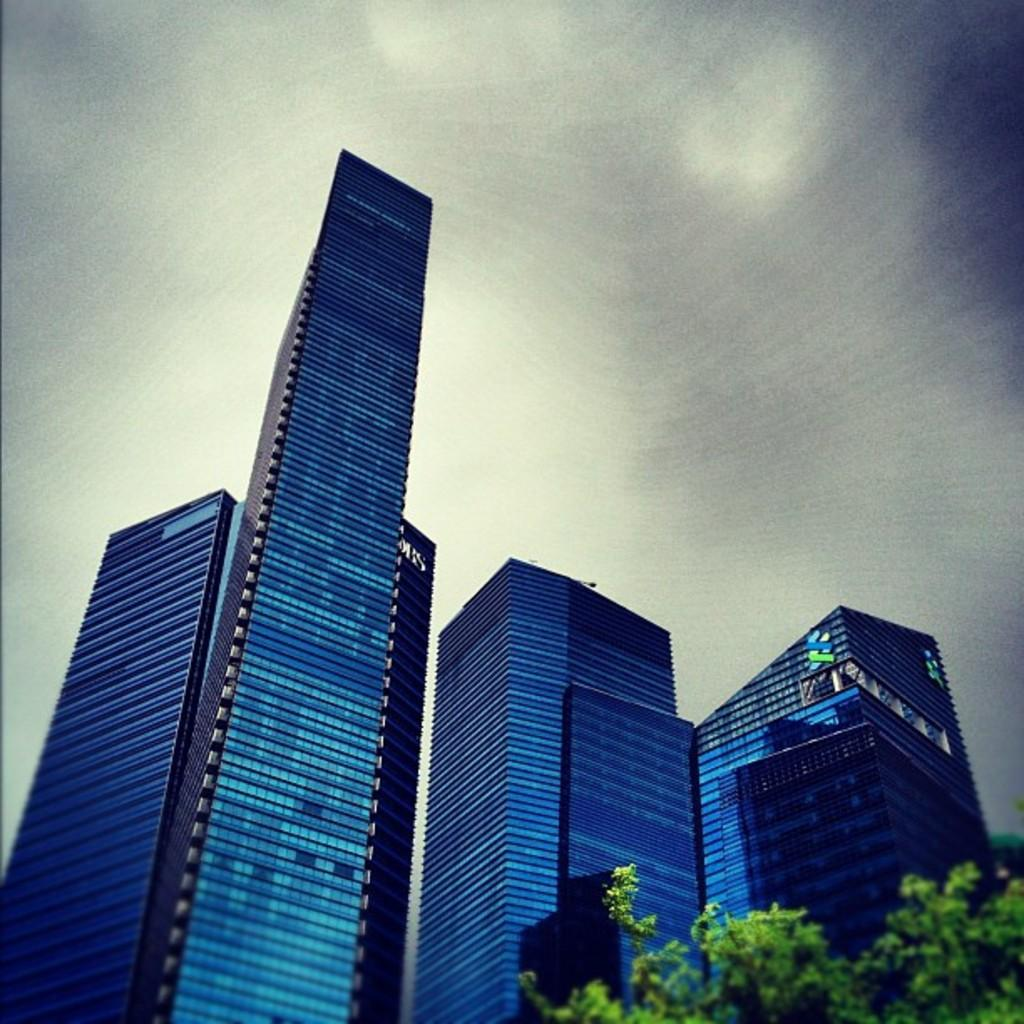What type of buildings can be seen in the image? There are glass buildings in the image. What other elements are present in the image besides the buildings? There are trees in the image. How would you describe the background of the image? The background of the image has a blurred view. What part of the natural environment is visible in the image? The sky is visible in the image. Where is the market located in the image? There is no market present in the image. What holiday is being celebrated in the image? There is no indication of a holiday being celebrated in the image. 